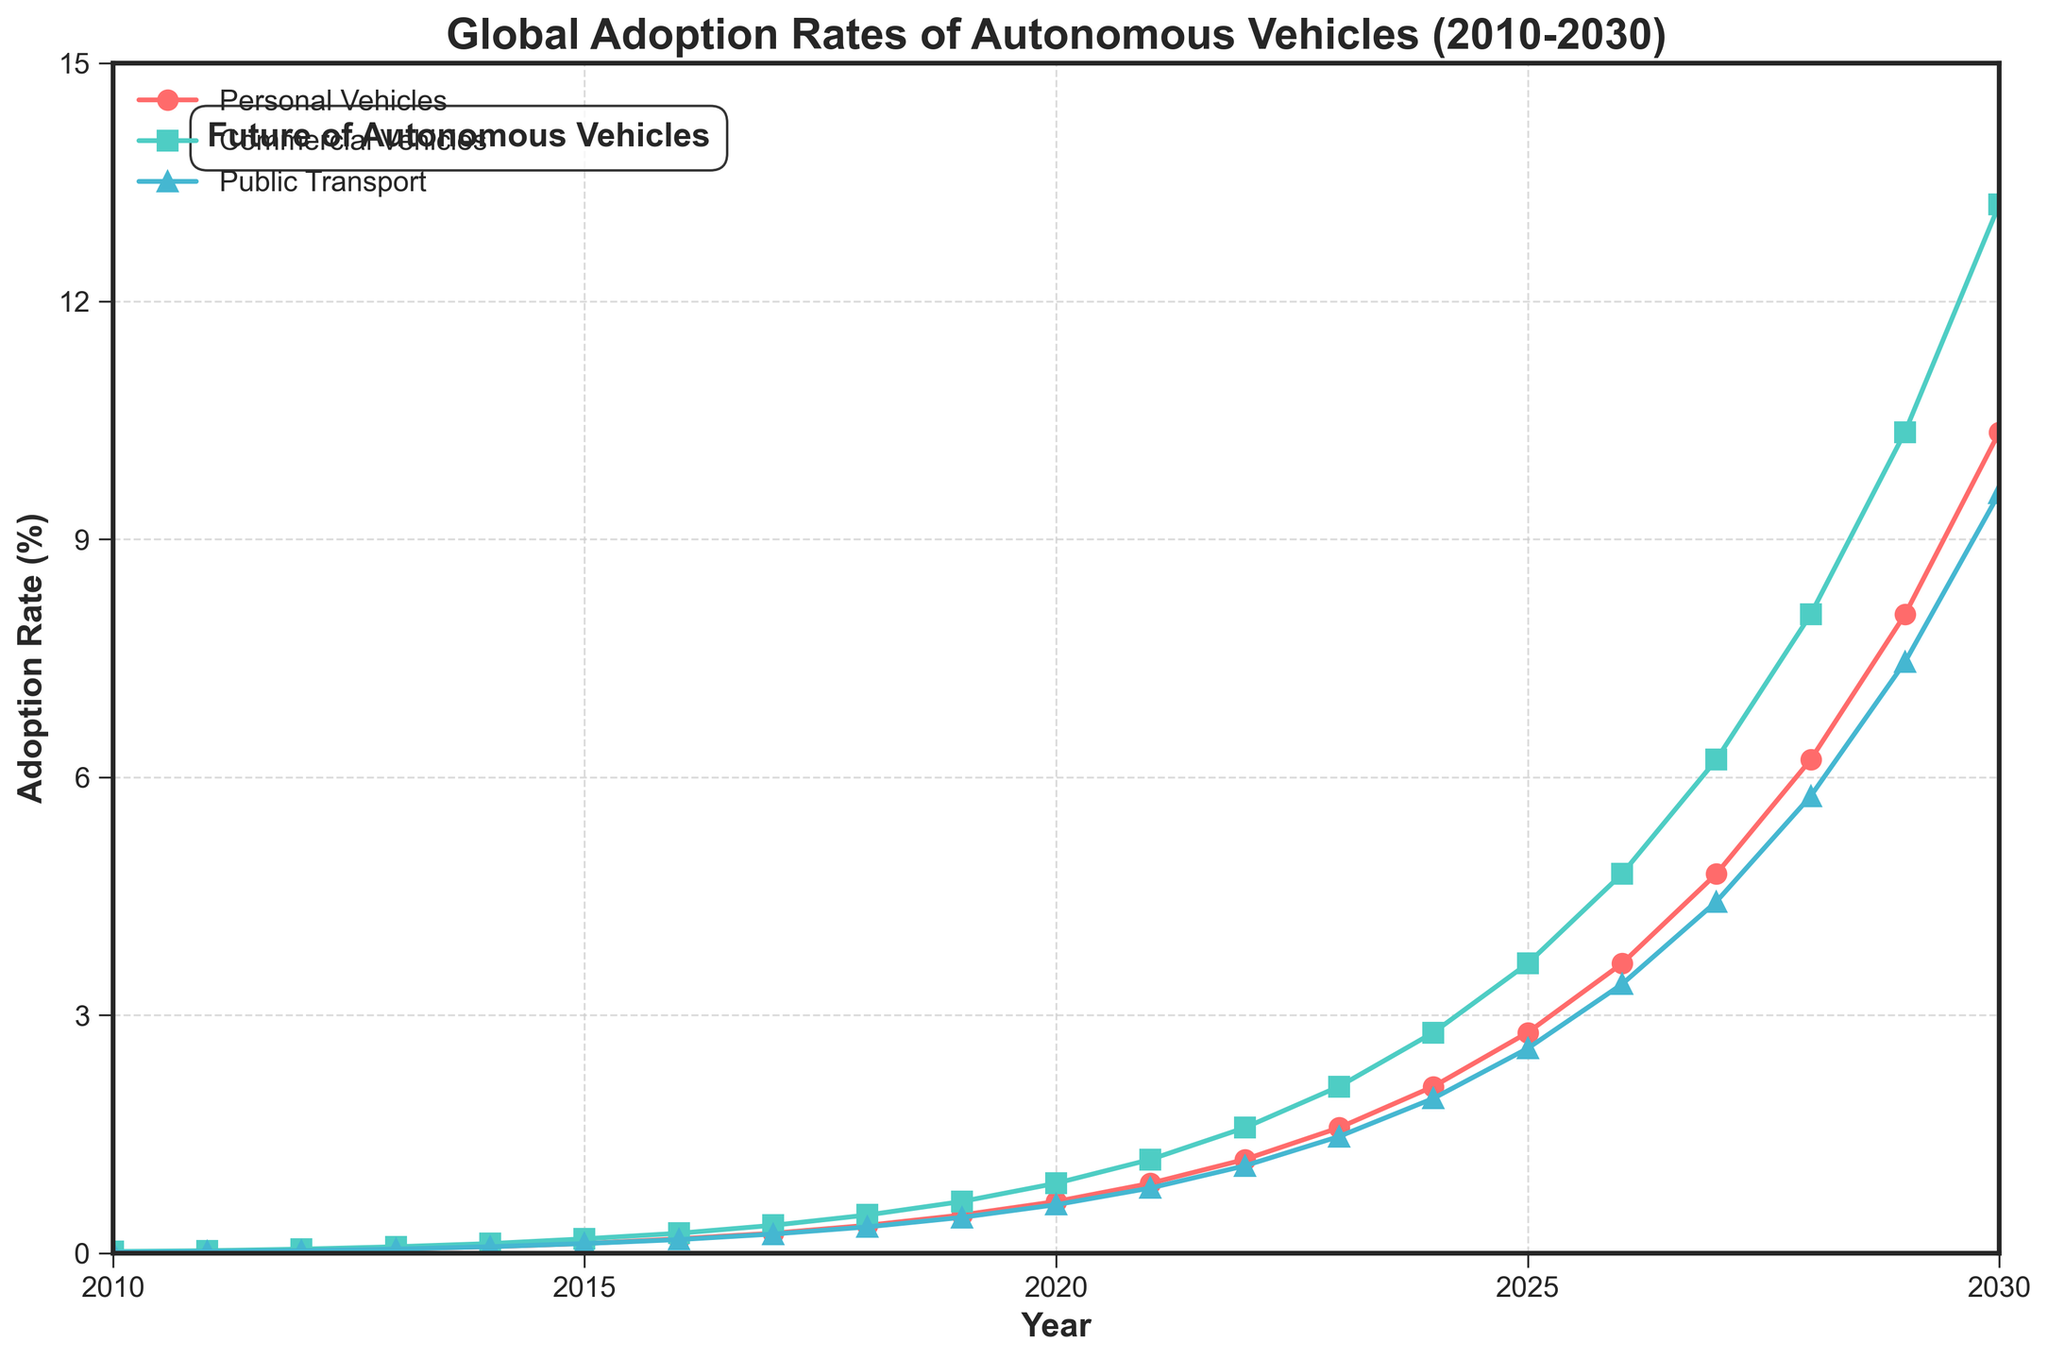What is the adoption rate of personal vehicles in 2020? From the figure, locate the year 2020 on the x-axis and refer to the value of the red line representing personal vehicles.
Answer: 0.65% Which type of vehicle had the highest adoption rate in 2030? From the figure, locate the year 2030 on the x-axis and compare the values of the red, green, and blue lines.
Answer: Commercial Vehicles How much did the adoption rate of public transport increase from 2010 to 2015? Refer to the values of the blue line in 2010 (0.01) and 2015 (0.12). Calculate the difference: 0.12 - 0.01 = 0.11.
Answer: 0.11 Which year saw the adoption rate of commercial vehicles surpass that of personal vehicles? Look for the year on the x-axis where the green line first goes above the red line.
Answer: 2015 How many years did it take for personal vehicle adoption to reach 1% from 0.01%? Identify the year when personal vehicle adoption reached 1% (2022) and subtract the starting year (2010): 2022 - 2010 = 12.
Answer: 12 years What is the average adoption rate of commercial vehicles between 2018 and 2020? By visually checking the figure, the values are 0.48 in 2018, 0.65 in 2019, and 0.88 in 2020. Calculate the average: (0.48 + 0.65 + 0.88) / 3 ≈ 0.67.
Answer: 0.67% In which year did all vehicle types show an adoption rate of at least 0.5%? Locate the year on the x-axis where all three lines (red, green, and blue) are above the 0.5% mark.
Answer: 2019 Which vehicle type had the slowest adoption rate growth between 2025 and 2030? Compare the growth of each vehicle type within the time frame by the difference in values from 2025 to 2030. Personal Vehicles: 10.35 - 2.78 = 7.57, Commercial Vehicles: 13.22 - 3.65 = 9.57, Public Transport: 9.58 - 2.58 = 7.00.
Answer: Public Transport What is the difference in adoption rates of commercial vehicles and public transport in 2025? Find the two adoption rates for 2025 and subtract them: 3.65 (commercial) - 2.58 (public) = 1.07.
Answer: 1.07% By how much did the adoption rate of autonomous public transport change from 2017 to 2027? Note the adoption rates in 2017 (0.24) and 2027 (4.43), then calculate the difference: 4.43 - 0.24 = 4.19.
Answer: 4.19% 